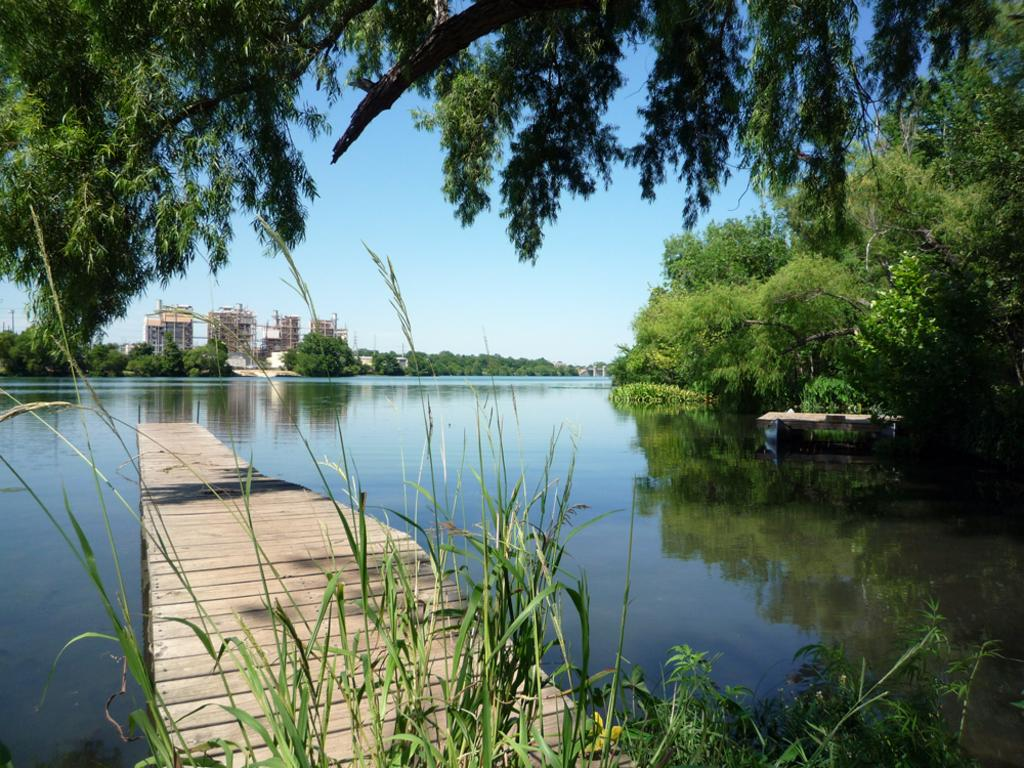What type of natural elements can be seen in the image? There are trees and plants visible in the image. What type of man-made structures are present in the image? There are buildings in the image. What is the boat's location in the image? The boat is on the water in the image. What part of the natural environment is visible in the background of the image? The sky is visible in the background of the image. What type of fuel is being used by the trees in the image? There is no mention of fuel in the image, as trees do not require fuel to grow or exist. What type of juice can be seen in the boat in the image? There is no juice visible in the boat or anywhere else in the image. 